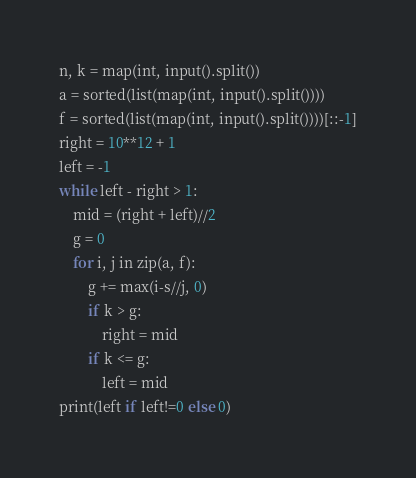Convert code to text. <code><loc_0><loc_0><loc_500><loc_500><_Python_>n, k = map(int, input().split())
a = sorted(list(map(int, input().split())))
f = sorted(list(map(int, input().split())))[::-1]
right = 10**12 + 1
left = -1
while left - right > 1:
    mid = (right + left)//2
    g = 0
    for i, j in zip(a, f):
        g += max(i-s//j, 0)
        if k > g:
            right = mid
        if k <= g:
            left = mid
print(left if left!=0 else 0)

</code> 